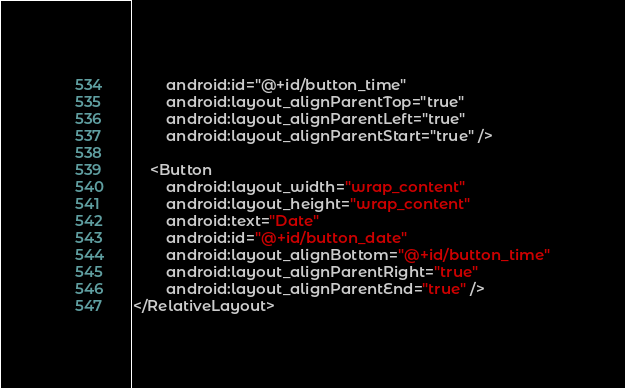Convert code to text. <code><loc_0><loc_0><loc_500><loc_500><_XML_>        android:id="@+id/button_time"
        android:layout_alignParentTop="true"
        android:layout_alignParentLeft="true"
        android:layout_alignParentStart="true" />

    <Button
        android:layout_width="wrap_content"
        android:layout_height="wrap_content"
        android:text="Date"
        android:id="@+id/button_date"
        android:layout_alignBottom="@+id/button_time"
        android:layout_alignParentRight="true"
        android:layout_alignParentEnd="true" />
</RelativeLayout>
</code> 